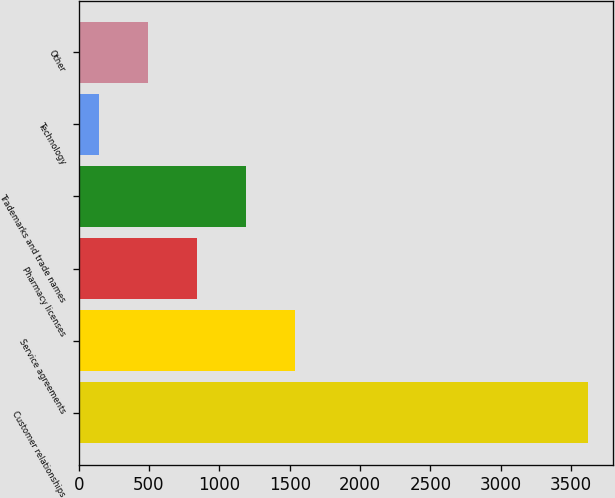<chart> <loc_0><loc_0><loc_500><loc_500><bar_chart><fcel>Customer relationships<fcel>Service agreements<fcel>Pharmacy licenses<fcel>Trademarks and trade names<fcel>Technology<fcel>Other<nl><fcel>3619<fcel>1535.8<fcel>841.4<fcel>1188.6<fcel>147<fcel>494.2<nl></chart> 